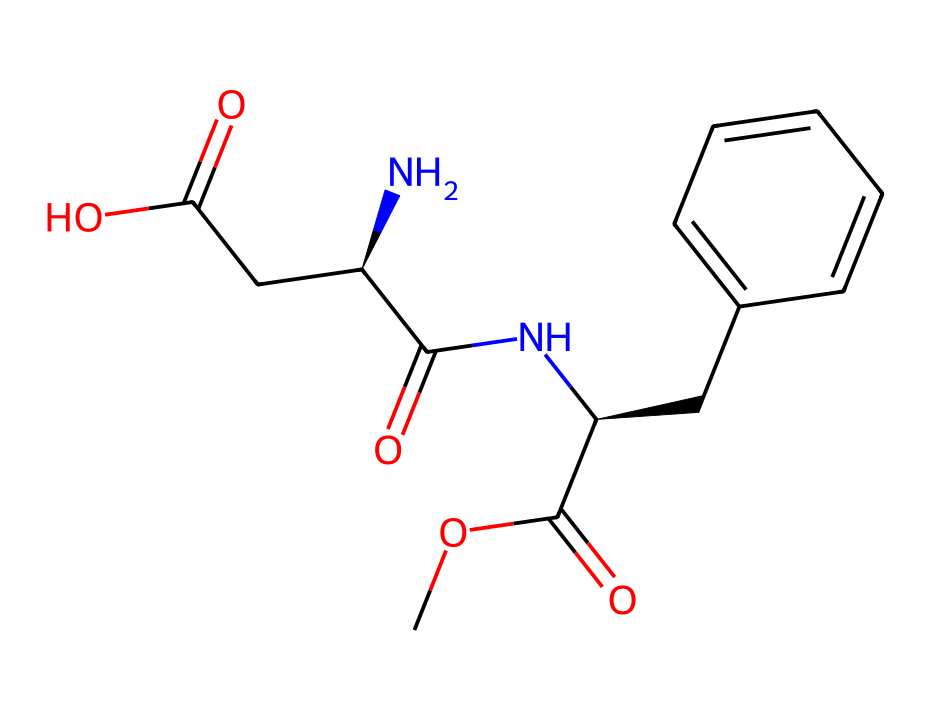What is the molecular formula of the compound represented by the SMILES? By analyzing the SMILES representation, we can count the number of each type of atom present. This will include counting carbons (C), hydrogens (H), nitrogens (N), and oxygens (O) based on the structure. The total counts give us the molecular formula, which is C15H19N3O5.
Answer: C15H19N3O5 How many chiral centers are in this compound? In the provided SMILES, we can identify chiral centers by looking for carbon atoms that are bonded to four different substituents. We observe that there are two such carbon centers.
Answer: 2 What type of functional groups are present in this structure? By examining the SMILES, we see various functional groups like esters (COC(=O)), amides (NC(=O)), and carboxylic acids (CC(=O)O). Each group contributes to the chemical's properties.
Answer: ester, amide, carboxylic acid Does this compound exhibit geometric isomerism? Geometric isomerism occurs due to restricted rotation around double bonds or rings. In this case, we find that the compound contains double bonds with substituents on either side that allow for cis/trans configurations. Therefore, it can exhibit geometric isomerism.
Answer: Yes What might be the implications of geometric isomerism for the biological activity of this sweetener? Geometric isomers can have different spatial arrangements of functional groups, which may affect how the compound interacts with biological receptors, potentially altering sweetness perception or metabolic pathways.
Answer: Different sweetness perception What is the primary use of this compound in beverages? The compound's structure indicates that it is an artificial sweetener, which implies its role is to provide sweetness without significant calories, making it popular in beverages marketed as low-calorie or sugar-free.
Answer: artificial sweetener How does this compound compare to traditional sweeteners in terms of caloric content? Generally, artificial sweeteners like this compound provide essentially zero calories as opposed to traditional sweeteners, which contain sugar and have high caloric content. This characteristic makes them preferable in low-calorie diets.
Answer: Zero calories 